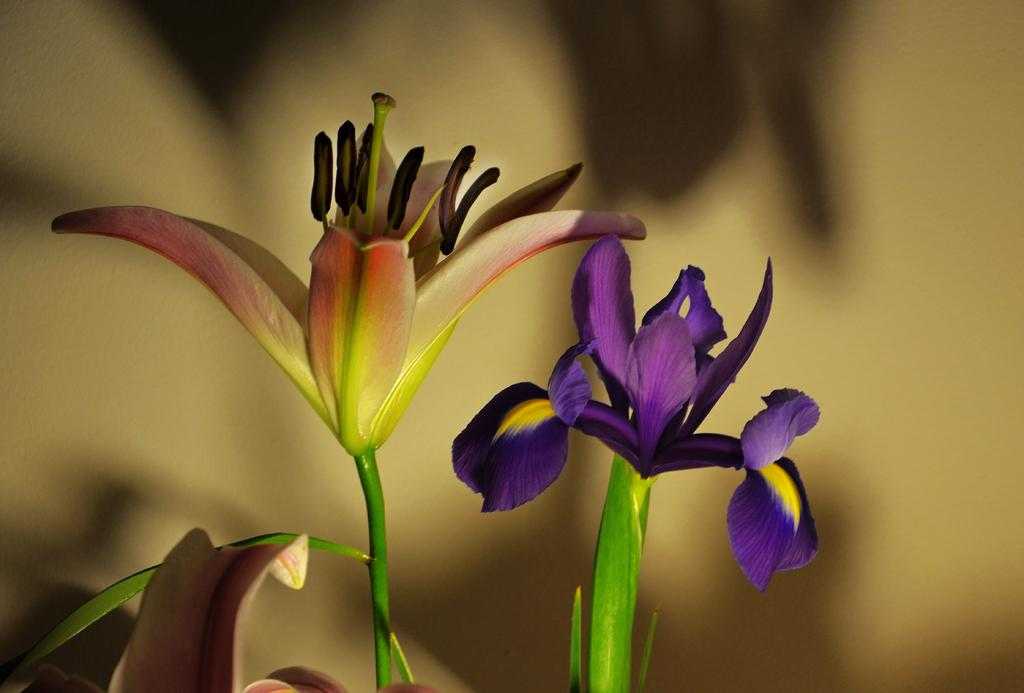What type of objects are featured in the image? There are stems with flowers in the image. Can you describe the background of the image? The background of the image is blurry. What type of tin can be seen in the image? There is no tin present in the image; it features stems with flowers and a blurry background. How does the mind interact with the flowers in the image? The image does not depict any interaction with the flowers or any representation of a mind; it simply shows stems with flowers and a blurry background. 